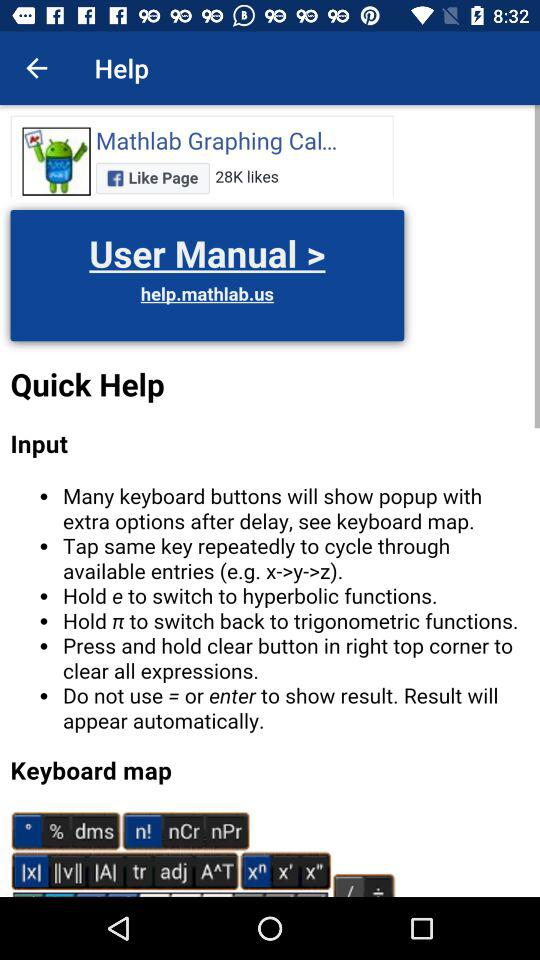How many likes are there? There are 28K likes. 